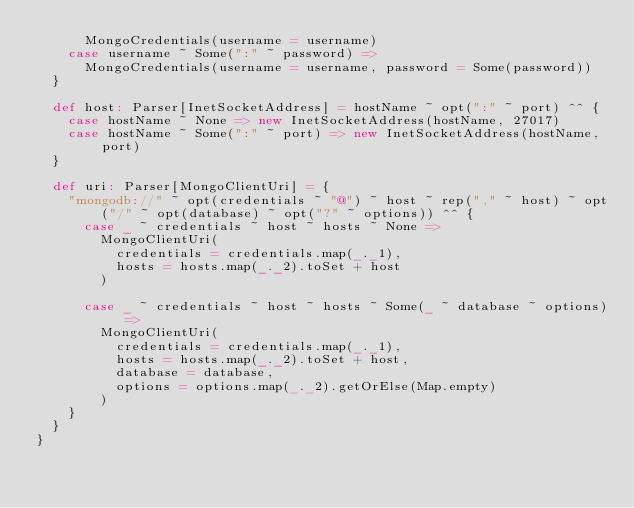Convert code to text. <code><loc_0><loc_0><loc_500><loc_500><_Scala_>      MongoCredentials(username = username)
    case username ~ Some(":" ~ password) =>
      MongoCredentials(username = username, password = Some(password))
  }

  def host: Parser[InetSocketAddress] = hostName ~ opt(":" ~ port) ^^ {
    case hostName ~ None => new InetSocketAddress(hostName, 27017)
    case hostName ~ Some(":" ~ port) => new InetSocketAddress(hostName, port)
  }

  def uri: Parser[MongoClientUri] = {
    "mongodb://" ~ opt(credentials ~ "@") ~ host ~ rep("," ~ host) ~ opt("/" ~ opt(database) ~ opt("?" ~ options)) ^^ {
      case _ ~ credentials ~ host ~ hosts ~ None =>
        MongoClientUri(
          credentials = credentials.map(_._1),
          hosts = hosts.map(_._2).toSet + host
        )

      case _ ~ credentials ~ host ~ hosts ~ Some(_ ~ database ~ options) =>
        MongoClientUri(
          credentials = credentials.map(_._1),
          hosts = hosts.map(_._2).toSet + host,
          database = database,
          options = options.map(_._2).getOrElse(Map.empty)
        )
    }
  }
}
</code> 